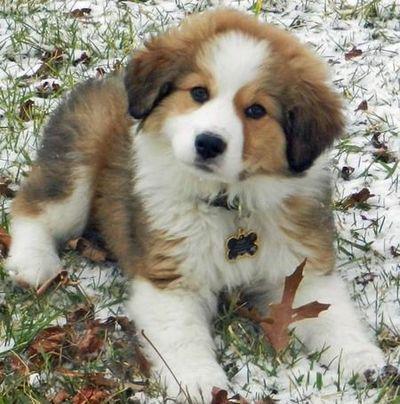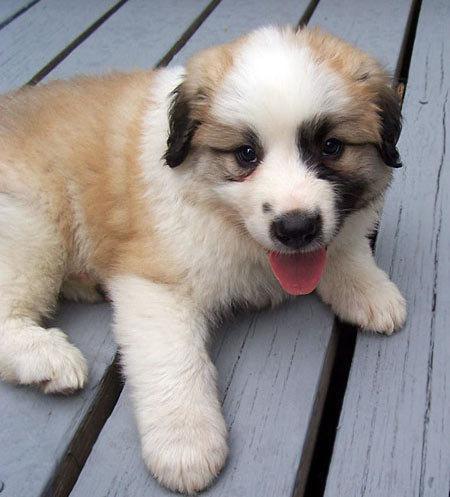The first image is the image on the left, the second image is the image on the right. For the images shown, is this caption "Each image shows one young puppy, and at least one image shows a brown-eared puppy reclining with its front paws forward." true? Answer yes or no. Yes. The first image is the image on the left, the second image is the image on the right. For the images shown, is this caption "One of the images features an adult dog on green grass." true? Answer yes or no. No. 